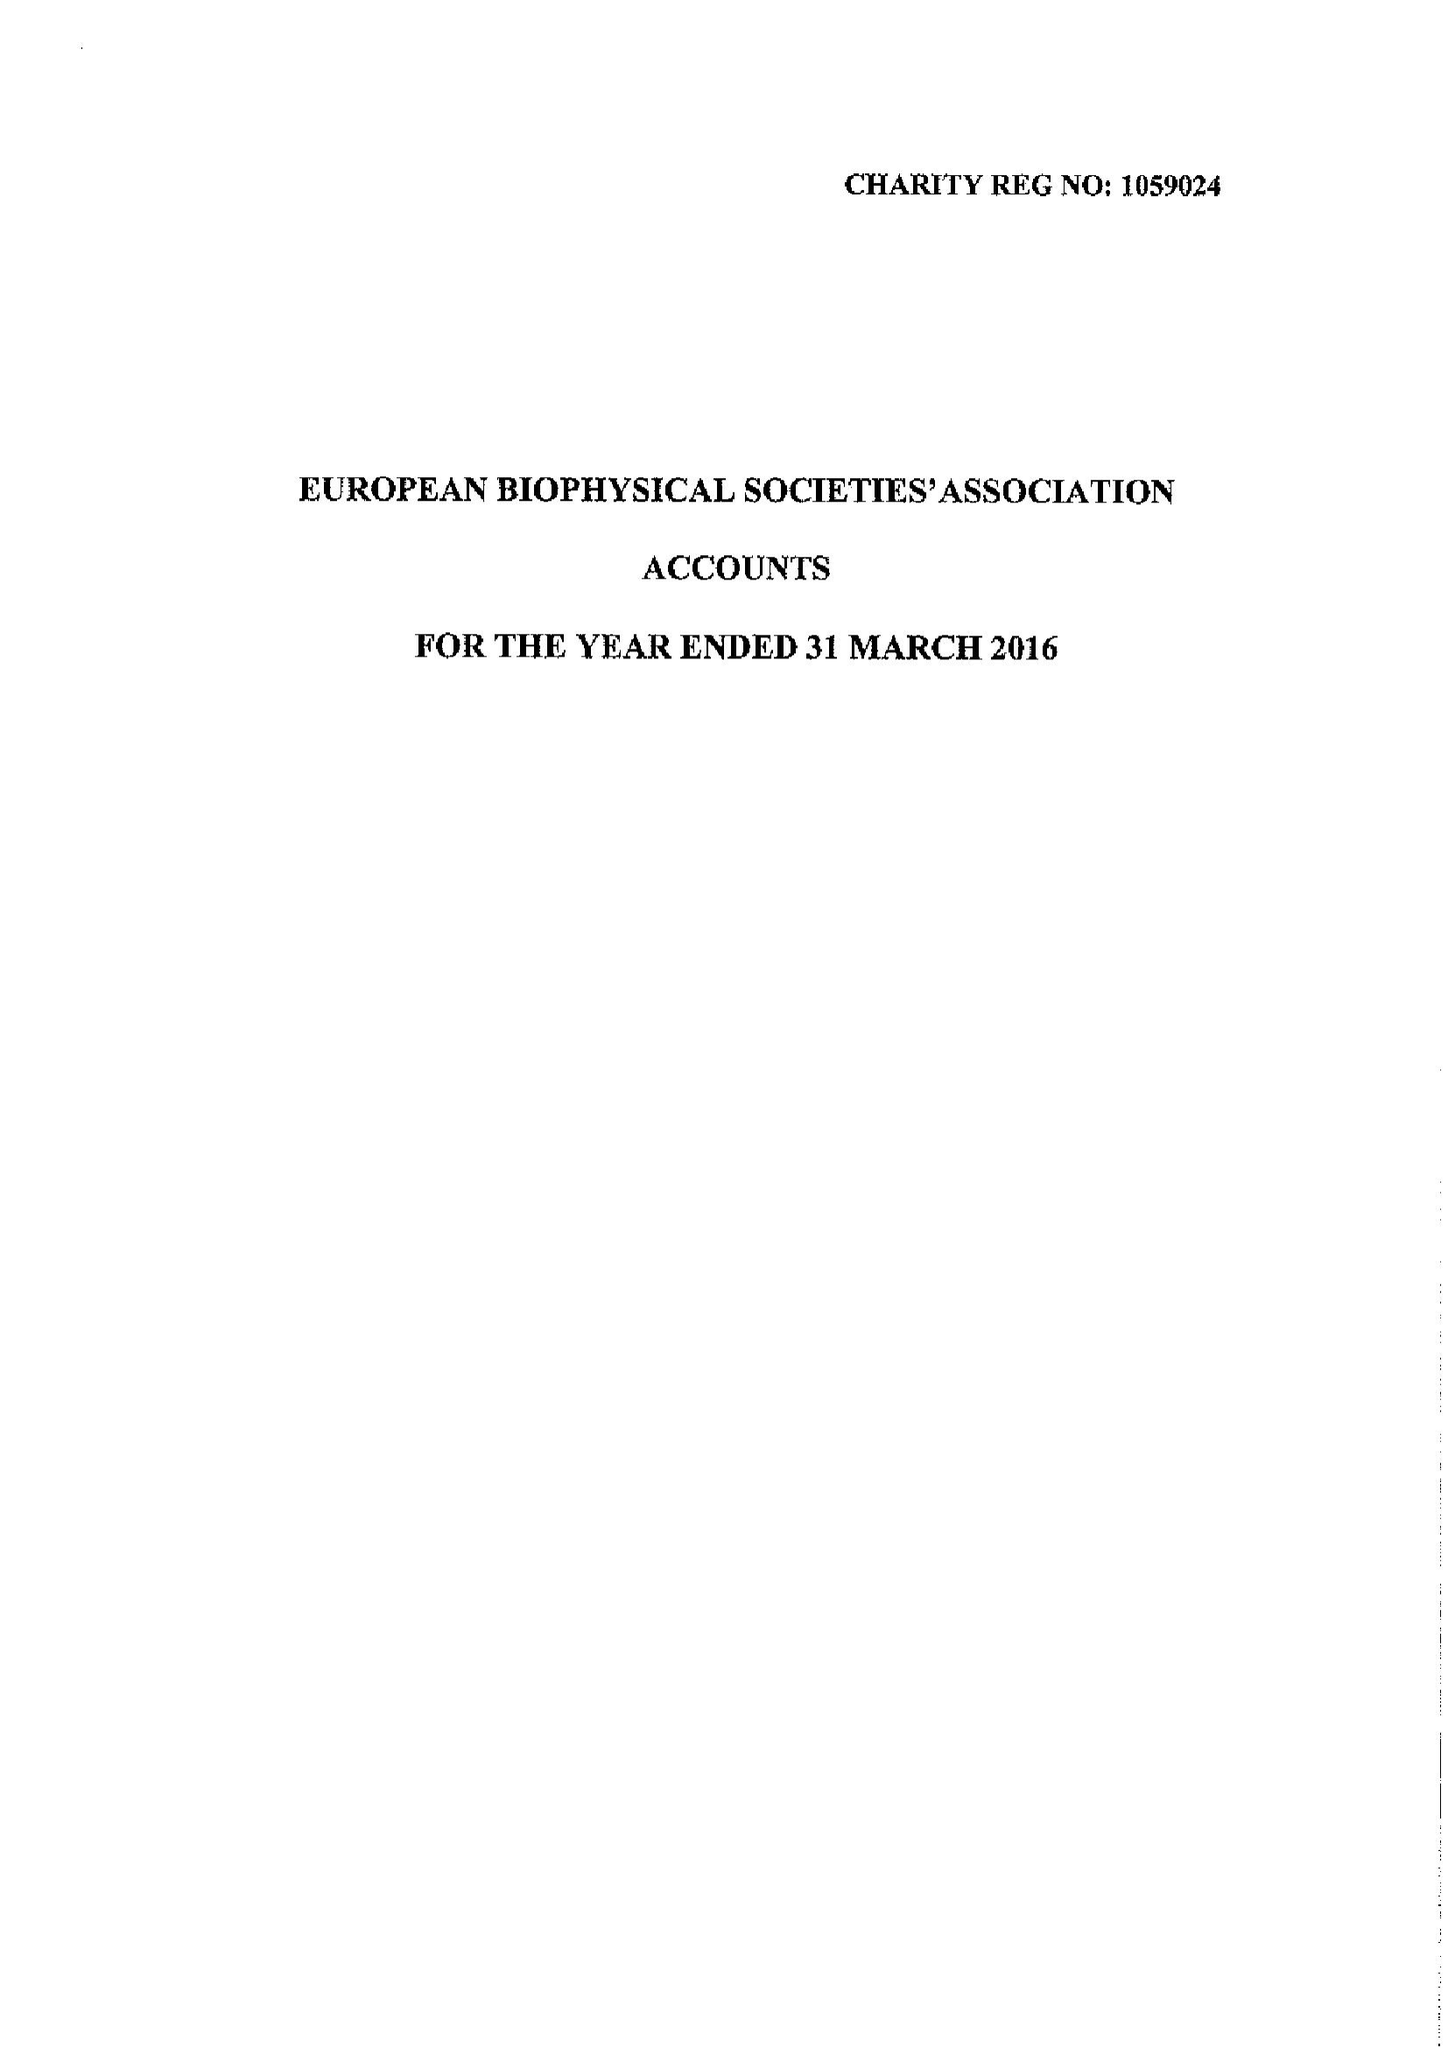What is the value for the report_date?
Answer the question using a single word or phrase. 2016-03-31 